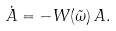Convert formula to latex. <formula><loc_0><loc_0><loc_500><loc_500>\dot { A } = - W ( \tilde { \omega } ) \, A .</formula> 